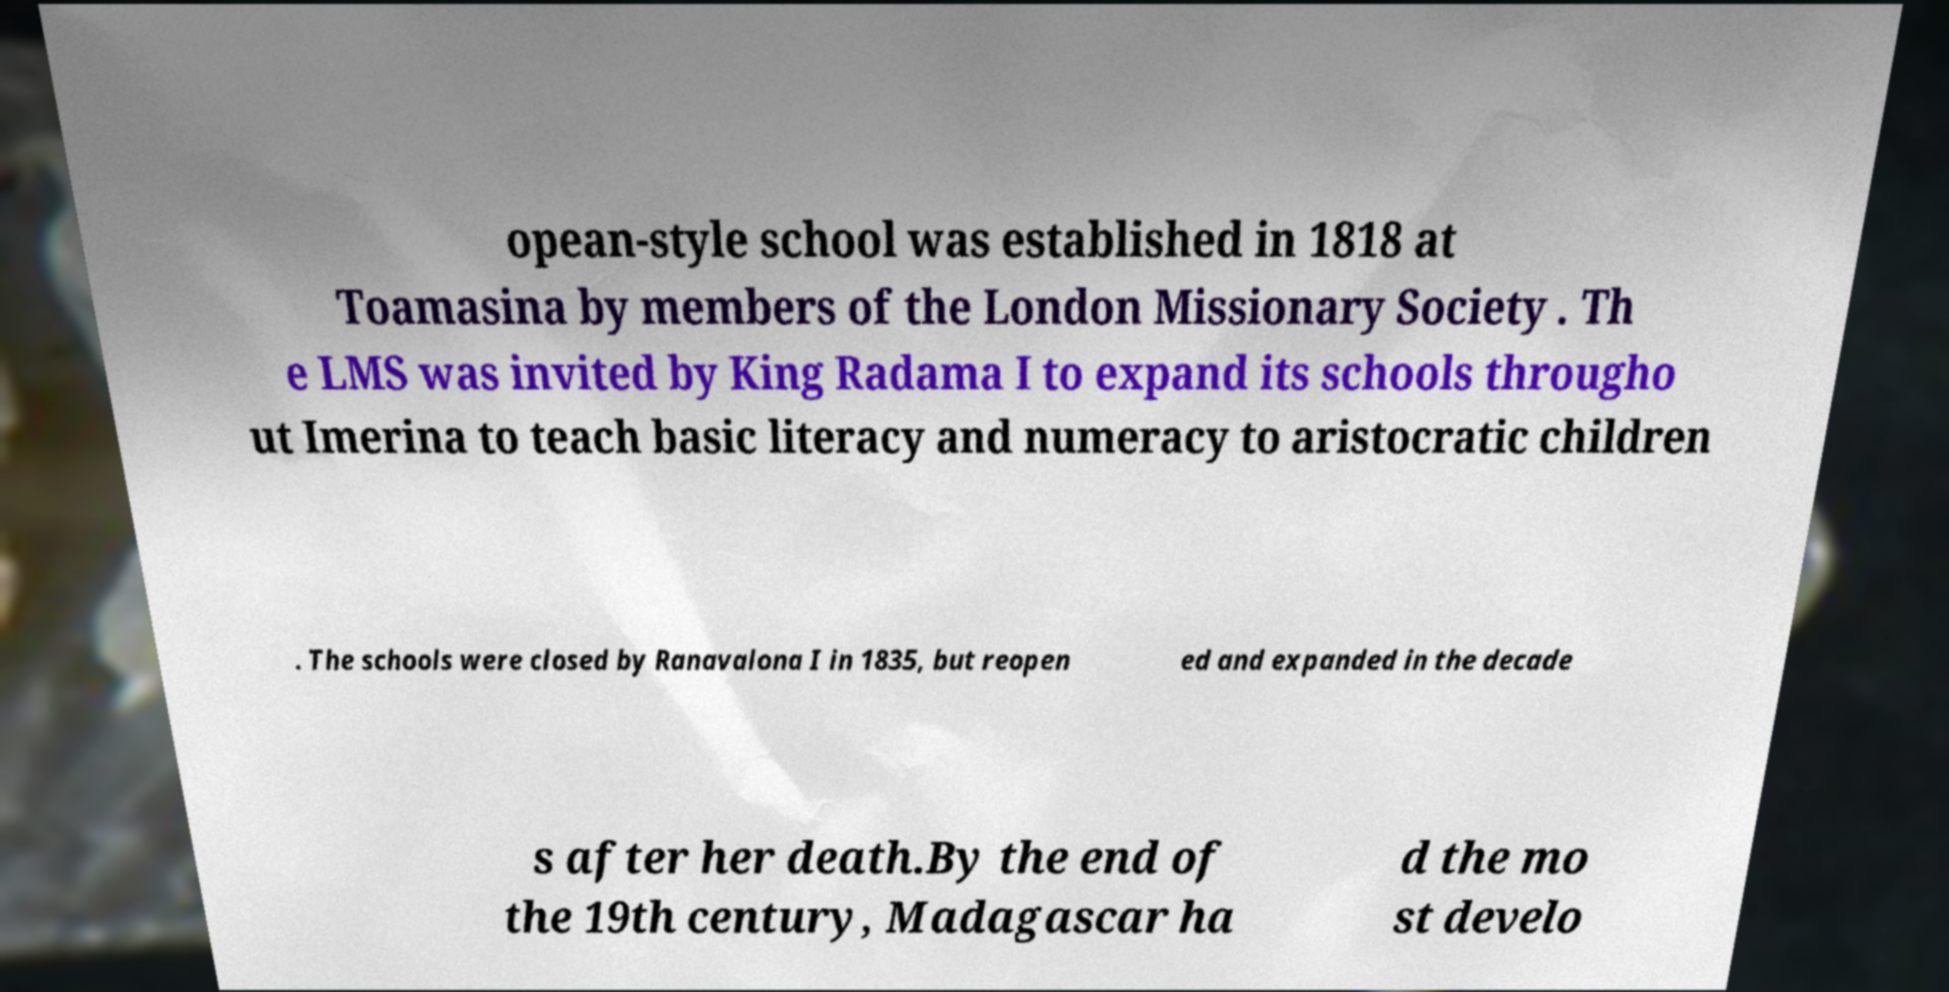I need the written content from this picture converted into text. Can you do that? opean-style school was established in 1818 at Toamasina by members of the London Missionary Society . Th e LMS was invited by King Radama I to expand its schools througho ut Imerina to teach basic literacy and numeracy to aristocratic children . The schools were closed by Ranavalona I in 1835, but reopen ed and expanded in the decade s after her death.By the end of the 19th century, Madagascar ha d the mo st develo 